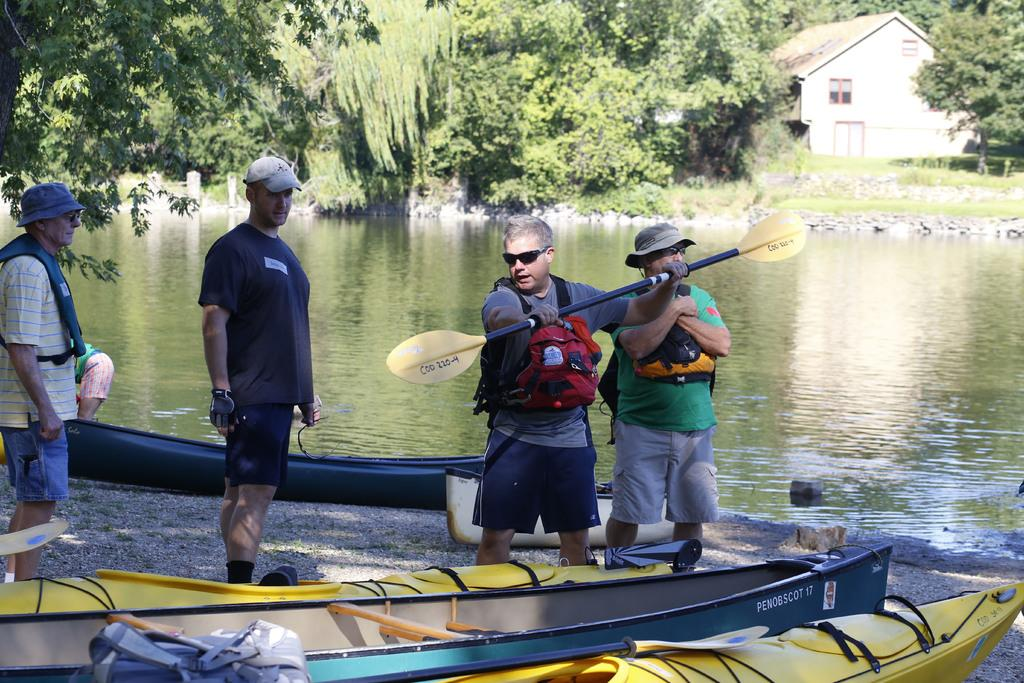What are the people in the image doing? The people in the image are standing. What is the man holding in the image? The man is holding a paddle. What else is the man carrying in the image? The man is carrying a bag. What type of vehicles can be seen in the image? There are boats visible in the image. What is the primary setting of the image? There is water in the image. What can be seen in the background of the image? There is a house, trees, and grass visible in the background of the image. What type of bushes can be seen in the image? There are no bushes present in the image. How does the man turn the paddle in the image? The image does not show the man turning the paddle, so it cannot be determined from the image. 